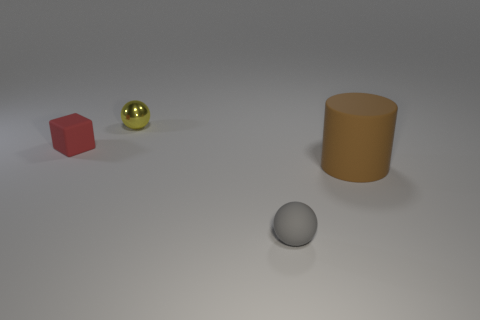Add 1 purple spheres. How many objects exist? 5 Subtract all cubes. How many objects are left? 3 Add 1 big brown things. How many big brown things exist? 2 Subtract 1 brown cylinders. How many objects are left? 3 Subtract all gray rubber spheres. Subtract all brown rubber spheres. How many objects are left? 3 Add 1 red objects. How many red objects are left? 2 